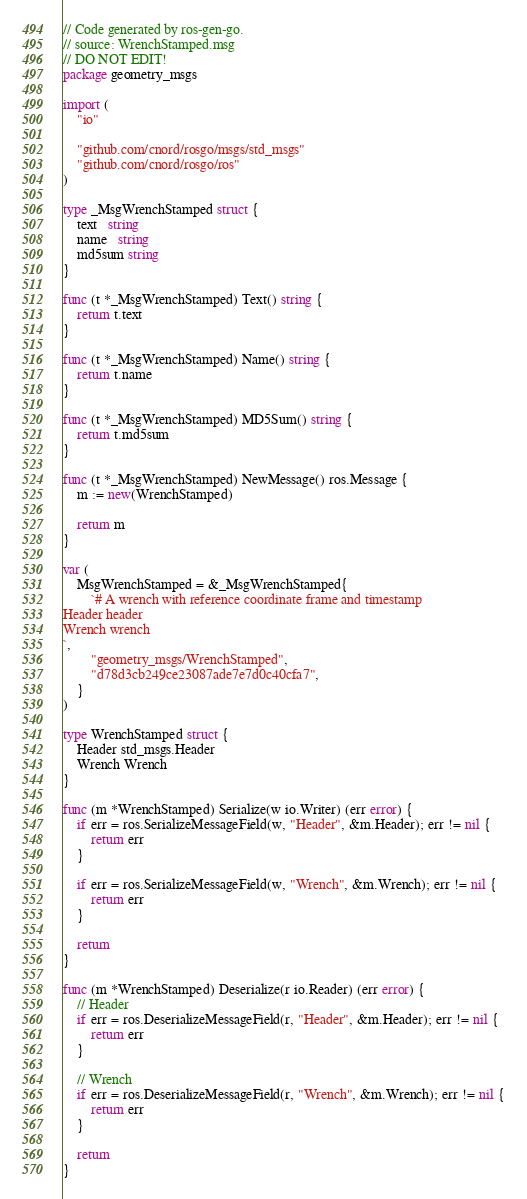Convert code to text. <code><loc_0><loc_0><loc_500><loc_500><_Go_>// Code generated by ros-gen-go.
// source: WrenchStamped.msg
// DO NOT EDIT!
package geometry_msgs

import (
	"io"

	"github.com/cnord/rosgo/msgs/std_msgs"
	"github.com/cnord/rosgo/ros"
)

type _MsgWrenchStamped struct {
	text   string
	name   string
	md5sum string
}

func (t *_MsgWrenchStamped) Text() string {
	return t.text
}

func (t *_MsgWrenchStamped) Name() string {
	return t.name
}

func (t *_MsgWrenchStamped) MD5Sum() string {
	return t.md5sum
}

func (t *_MsgWrenchStamped) NewMessage() ros.Message {
	m := new(WrenchStamped)

	return m
}

var (
	MsgWrenchStamped = &_MsgWrenchStamped{
		`# A wrench with reference coordinate frame and timestamp
Header header
Wrench wrench
`,
		"geometry_msgs/WrenchStamped",
		"d78d3cb249ce23087ade7e7d0c40cfa7",
	}
)

type WrenchStamped struct {
	Header std_msgs.Header
	Wrench Wrench
}

func (m *WrenchStamped) Serialize(w io.Writer) (err error) {
	if err = ros.SerializeMessageField(w, "Header", &m.Header); err != nil {
		return err
	}

	if err = ros.SerializeMessageField(w, "Wrench", &m.Wrench); err != nil {
		return err
	}

	return
}

func (m *WrenchStamped) Deserialize(r io.Reader) (err error) {
	// Header
	if err = ros.DeserializeMessageField(r, "Header", &m.Header); err != nil {
		return err
	}

	// Wrench
	if err = ros.DeserializeMessageField(r, "Wrench", &m.Wrench); err != nil {
		return err
	}

	return
}
</code> 